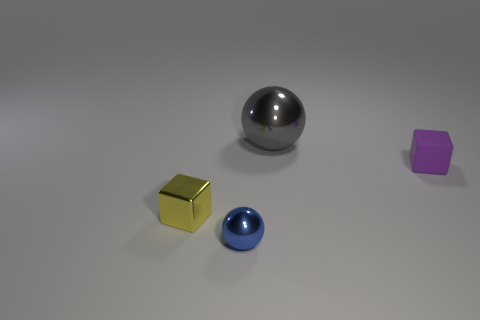Subtract all purple cubes. How many cubes are left? 1 Add 4 small green rubber blocks. How many objects exist? 8 Subtract 1 spheres. How many spheres are left? 1 Add 4 large metal things. How many large metal things are left? 5 Add 4 small blue matte spheres. How many small blue matte spheres exist? 4 Subtract 1 yellow cubes. How many objects are left? 3 Subtract all green balls. Subtract all purple cylinders. How many balls are left? 2 Subtract all blue cylinders. How many brown blocks are left? 0 Subtract all large blue spheres. Subtract all large gray spheres. How many objects are left? 3 